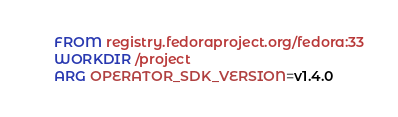<code> <loc_0><loc_0><loc_500><loc_500><_Dockerfile_>FROM registry.fedoraproject.org/fedora:33
WORKDIR /project
ARG OPERATOR_SDK_VERSION=v1.4.0</code> 